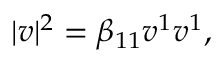<formula> <loc_0><loc_0><loc_500><loc_500>| v | ^ { 2 } = \beta _ { 1 1 } v ^ { 1 } v ^ { 1 } ,</formula> 